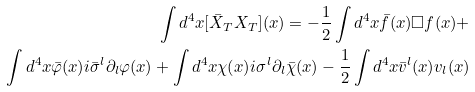<formula> <loc_0><loc_0><loc_500><loc_500>\int d ^ { 4 } x [ \bar { X } _ { T } X _ { T } ] ( x ) = - \frac { 1 } { 2 } \int d ^ { 4 } x \bar { f } ( x ) \square f ( x ) + \\ \int d ^ { 4 } x \bar { \varphi } ( x ) i \bar { \sigma } ^ { l } \partial _ { l } \varphi ( x ) + \int d ^ { 4 } x \chi ( x ) i \sigma ^ { l } \partial _ { l } \bar { \chi } ( x ) - \frac { 1 } { 2 } \int d ^ { 4 } x \bar { v } ^ { l } ( x ) v _ { l } ( x )</formula> 